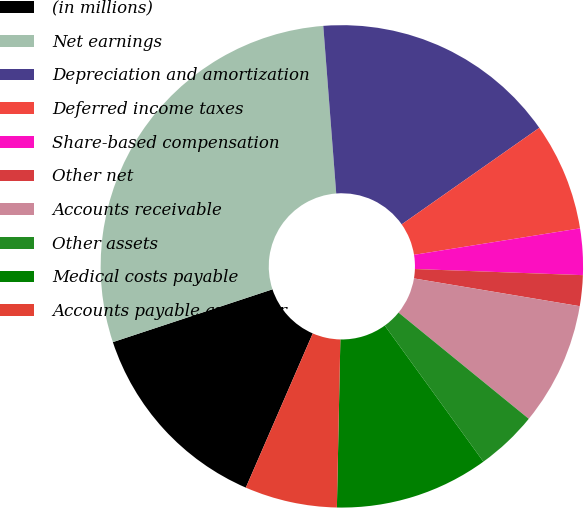Convert chart to OTSL. <chart><loc_0><loc_0><loc_500><loc_500><pie_chart><fcel>(in millions)<fcel>Net earnings<fcel>Depreciation and amortization<fcel>Deferred income taxes<fcel>Share-based compensation<fcel>Other net<fcel>Accounts receivable<fcel>Other assets<fcel>Medical costs payable<fcel>Accounts payable and other<nl><fcel>13.4%<fcel>28.86%<fcel>16.49%<fcel>7.22%<fcel>3.1%<fcel>2.06%<fcel>8.25%<fcel>4.13%<fcel>10.31%<fcel>6.19%<nl></chart> 